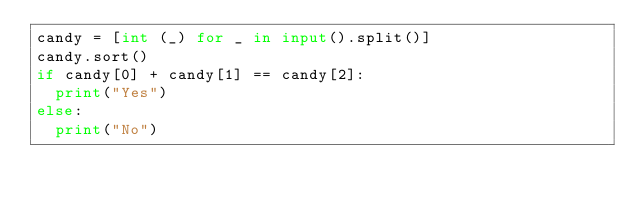Convert code to text. <code><loc_0><loc_0><loc_500><loc_500><_Python_>candy = [int (_) for _ in input().split()]
candy.sort()
if candy[0] + candy[1] == candy[2]:
  print("Yes")
else:
  print("No")</code> 